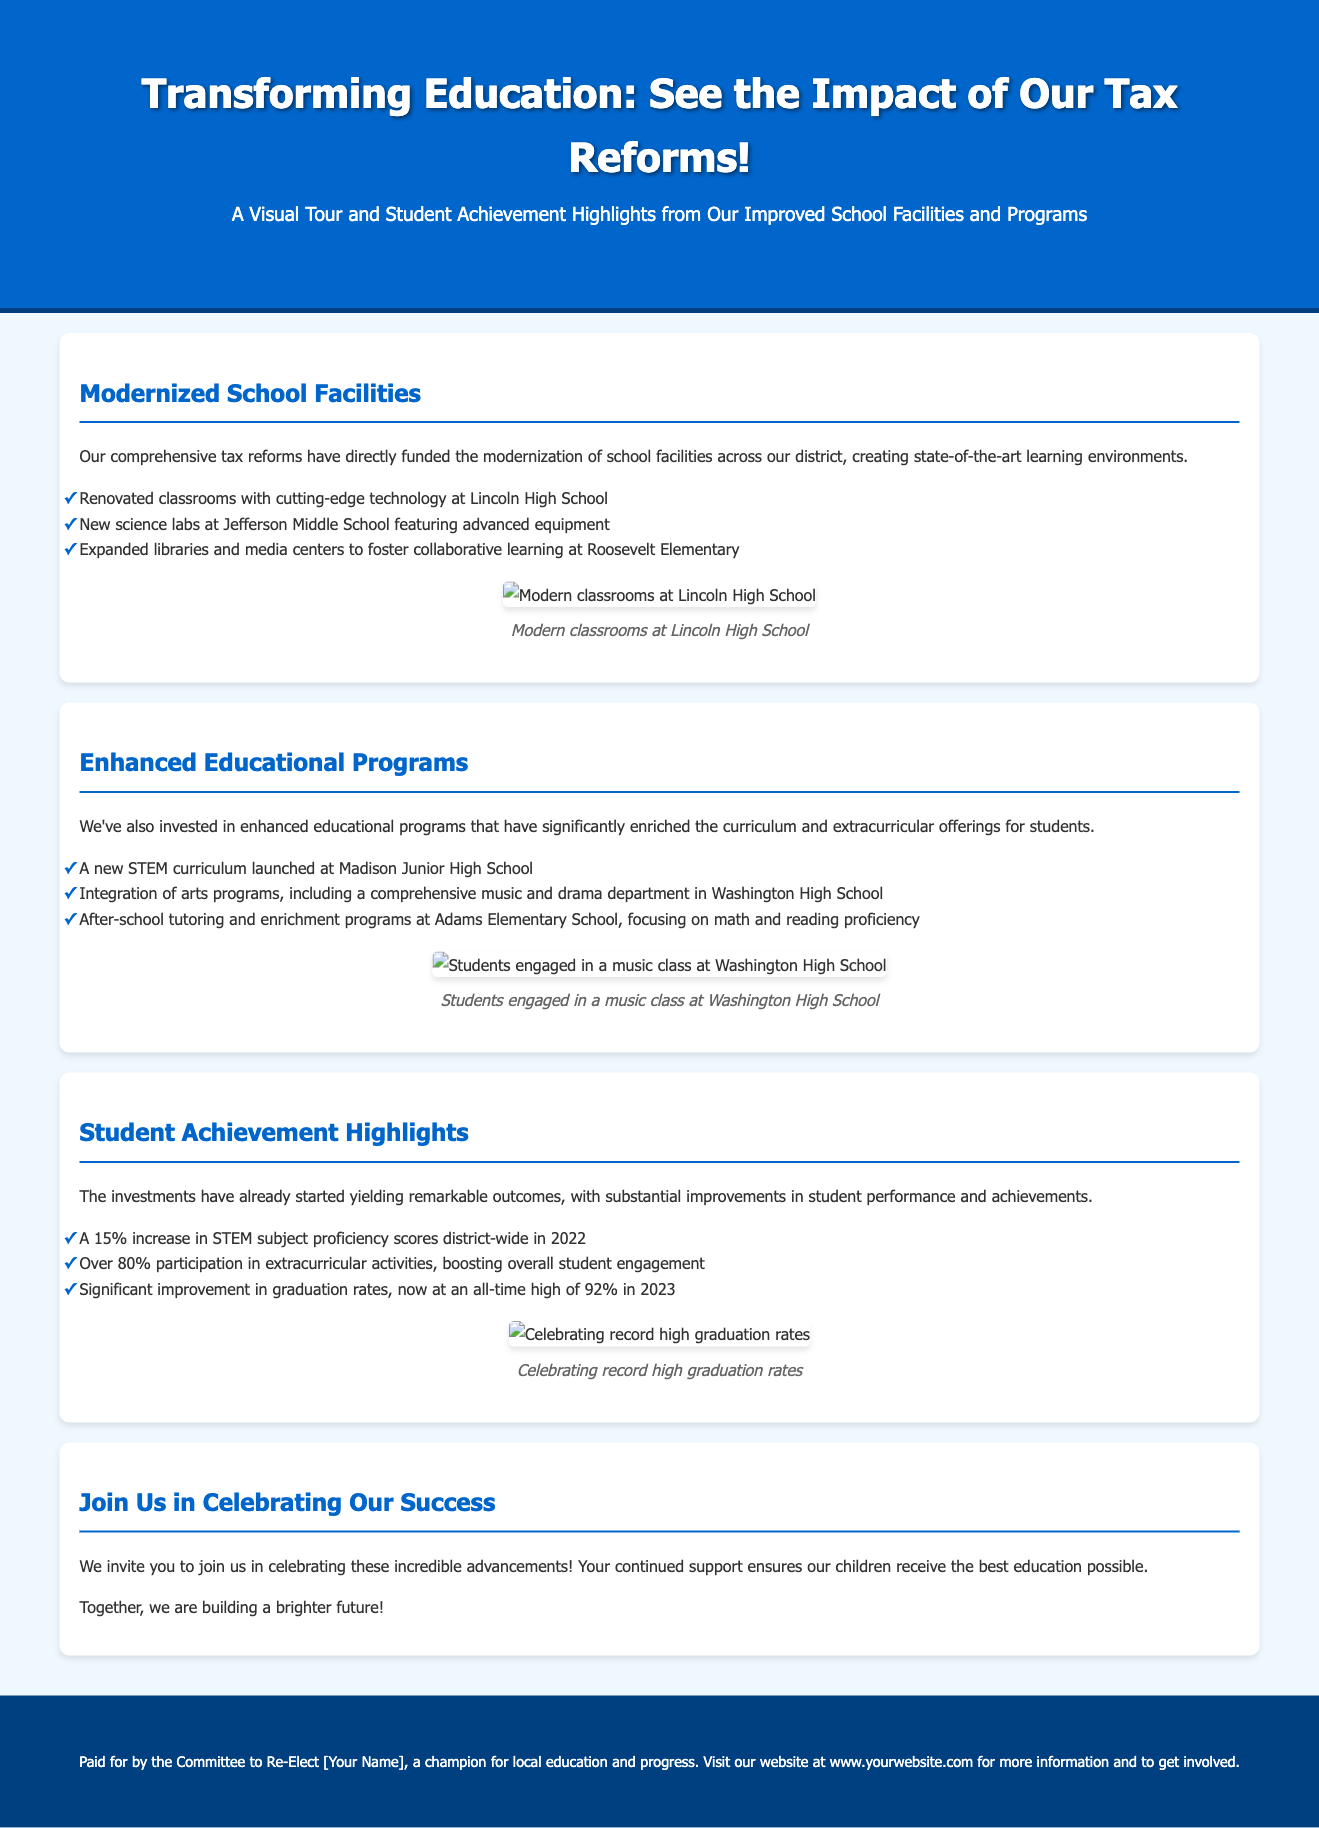what is the title of the advertisement? The title of the advertisement is found in the header section, indicating the main theme of the document.
Answer: Transforming Education: See the Impact of Our Tax Reforms! what percentage increase in STEM subject proficiency scores was achieved? This information is detailed in the Student Achievement Highlights section, emphasizing academic improvements.
Answer: 15% which school features renovated classrooms with cutting-edge technology? This specific information is listed under the Modernized School Facilities section, highlighting individual school improvements.
Answer: Lincoln High School how many student participation rate in extracurricular activities is noted? The document provides specific data on participation rates in the Student Achievement Highlights section.
Answer: Over 80% which new curriculum was launched at Madison Junior High School? This information can be found in the Enhanced Educational Programs section describing curriculum enhancements.
Answer: STEM curriculum what is the current graduation rate mentioned in the document? The graduation rate is stated in the Student Achievement Highlights section, showcasing the success of educational reforms.
Answer: 92% what type of improvements were made at Roosevelt Elementary? This detail is included in the Modernized School Facilities section, describing facility enhancements.
Answer: Expanded libraries and media centers what is the main purpose of the advertisement? The purpose is expressed in the concluding section, inviting community engagement in educational advancements.
Answer: Celebrating these incredible advancements what does the advertisement invite the community to do? The invitation is found in the last section, encouraging community participation and support for education.
Answer: Join Us in Celebrating Our Success 